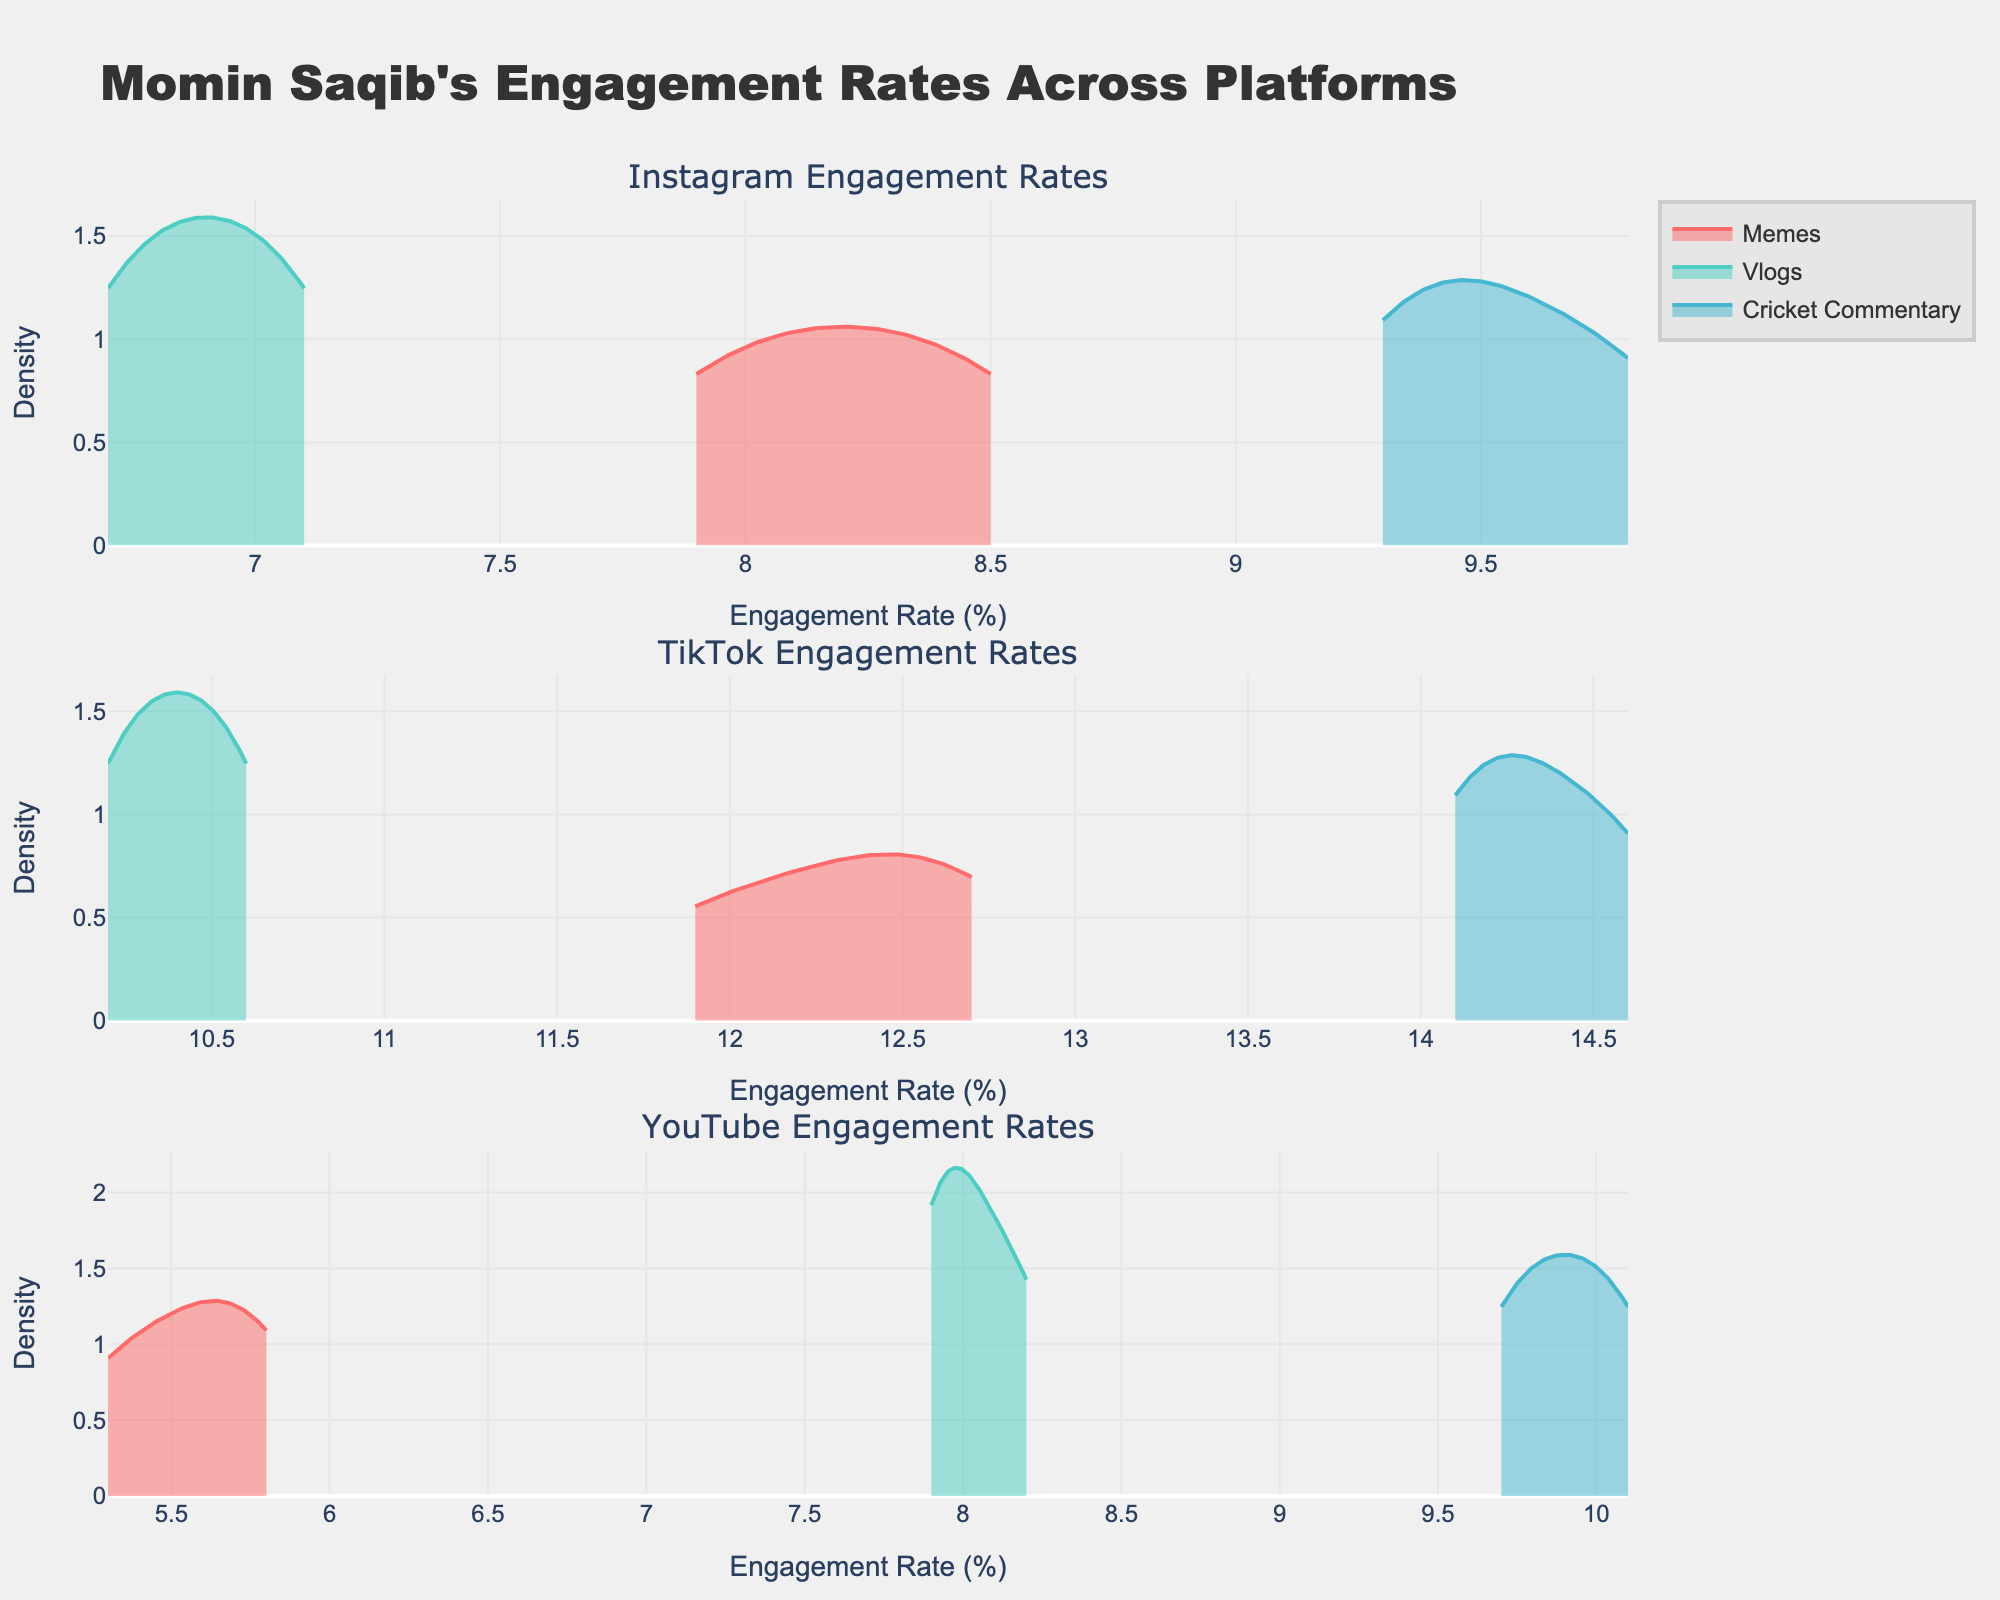What is the title of the figure? The title of the figure is found at the top, indicating what the visual data represents. The title here is "Momin Saqib's Engagement Rates Across Platforms".
Answer: Momin Saqib's Engagement Rates Across Platforms Which content type on Instagram has the highest density peak? Look at the different density plots for Instagram and identify which one reaches the highest point on the vertical axis. "Cricket Commentary" has the highest density peak on the Instagram subplot.
Answer: Cricket Commentary Between TikTok and YouTube, which platform shows higher engagement rates for "Cricket Commentary"? Compare the density plots for "Cricket Commentary" on TikTok and YouTube. TikTok's densities for "Cricket Commentary" are higher, indicating higher engagement rates.
Answer: TikTok What are the colors used for the "Memes" content type in the figure? Each content type has a specific color assigned. "Memes" are represented in shades of red across all platforms.
Answer: Red Which platform has the widest range of engagement rates for "Vlogs"? Examine the range of engagement rates for "Vlogs" across the different platforms by looking at the horizontal spread of the density plots. YouTube shows a wider range of engagement rates for "Vlogs" compared to other platforms.
Answer: YouTube What is the average peak density for engagement rates of "Memes" across all platforms? Calculate the average of the peak densities for "Memes" on Instagram, TikTok, and YouTube. Assuming the peak densities are approximately 0.45, 0.6, and 0.3 for each platform, respectively, the average is (0.45 + 0.6 + 0.3) / 3.
Answer: 0.45 Which content type on YouTube has engagement rates closest to 10%? Identify the density plots for YouTube and look for the one peaking around the 10% mark. "Cricket Commentary" has engagement rates closest to 10%.
Answer: Cricket Commentary Is the density of "Vlogs" on TikTok higher than on Instagram at lower engagement rates (below 8.0%)? Compare the density plots of "Vlogs" on TikTok and Instagram specifically at the lower engagement rates. On TikTok, the density of "Vlogs" remains around 10.2% and higher, so it's not applicable to engagement rates below 8%.
Answer: No What does the color turquoise represent in the figure? Identify which content type is represented by the color turquoise. Upon examining the density plots, turquoise corresponds to "Vlogs".
Answer: Vlogs 